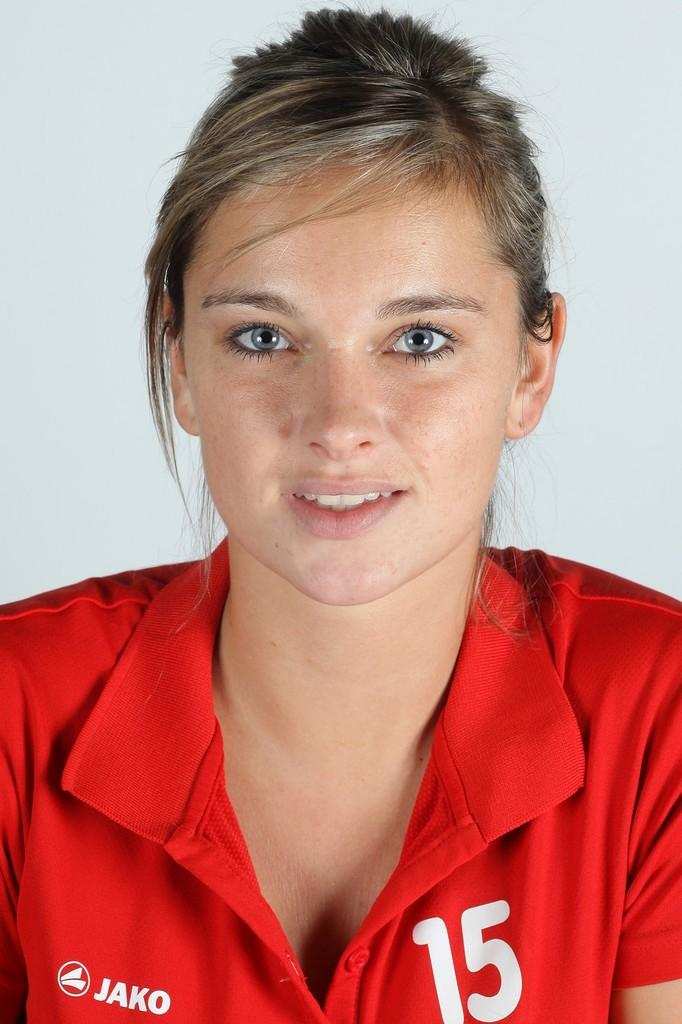Who is the main subject in the image? There is a lady in the image. What is the lady wearing? The lady is wearing a red t-shirt. Are there any specific details on the t-shirt? Yes, there is writing and a number on the t-shirt. How much wealth does the lady have, as indicated by the number on her t-shirt? There is no indication of wealth or any financial context in the image, as the number on the t-shirt is likely unrelated to the lady's financial status. 